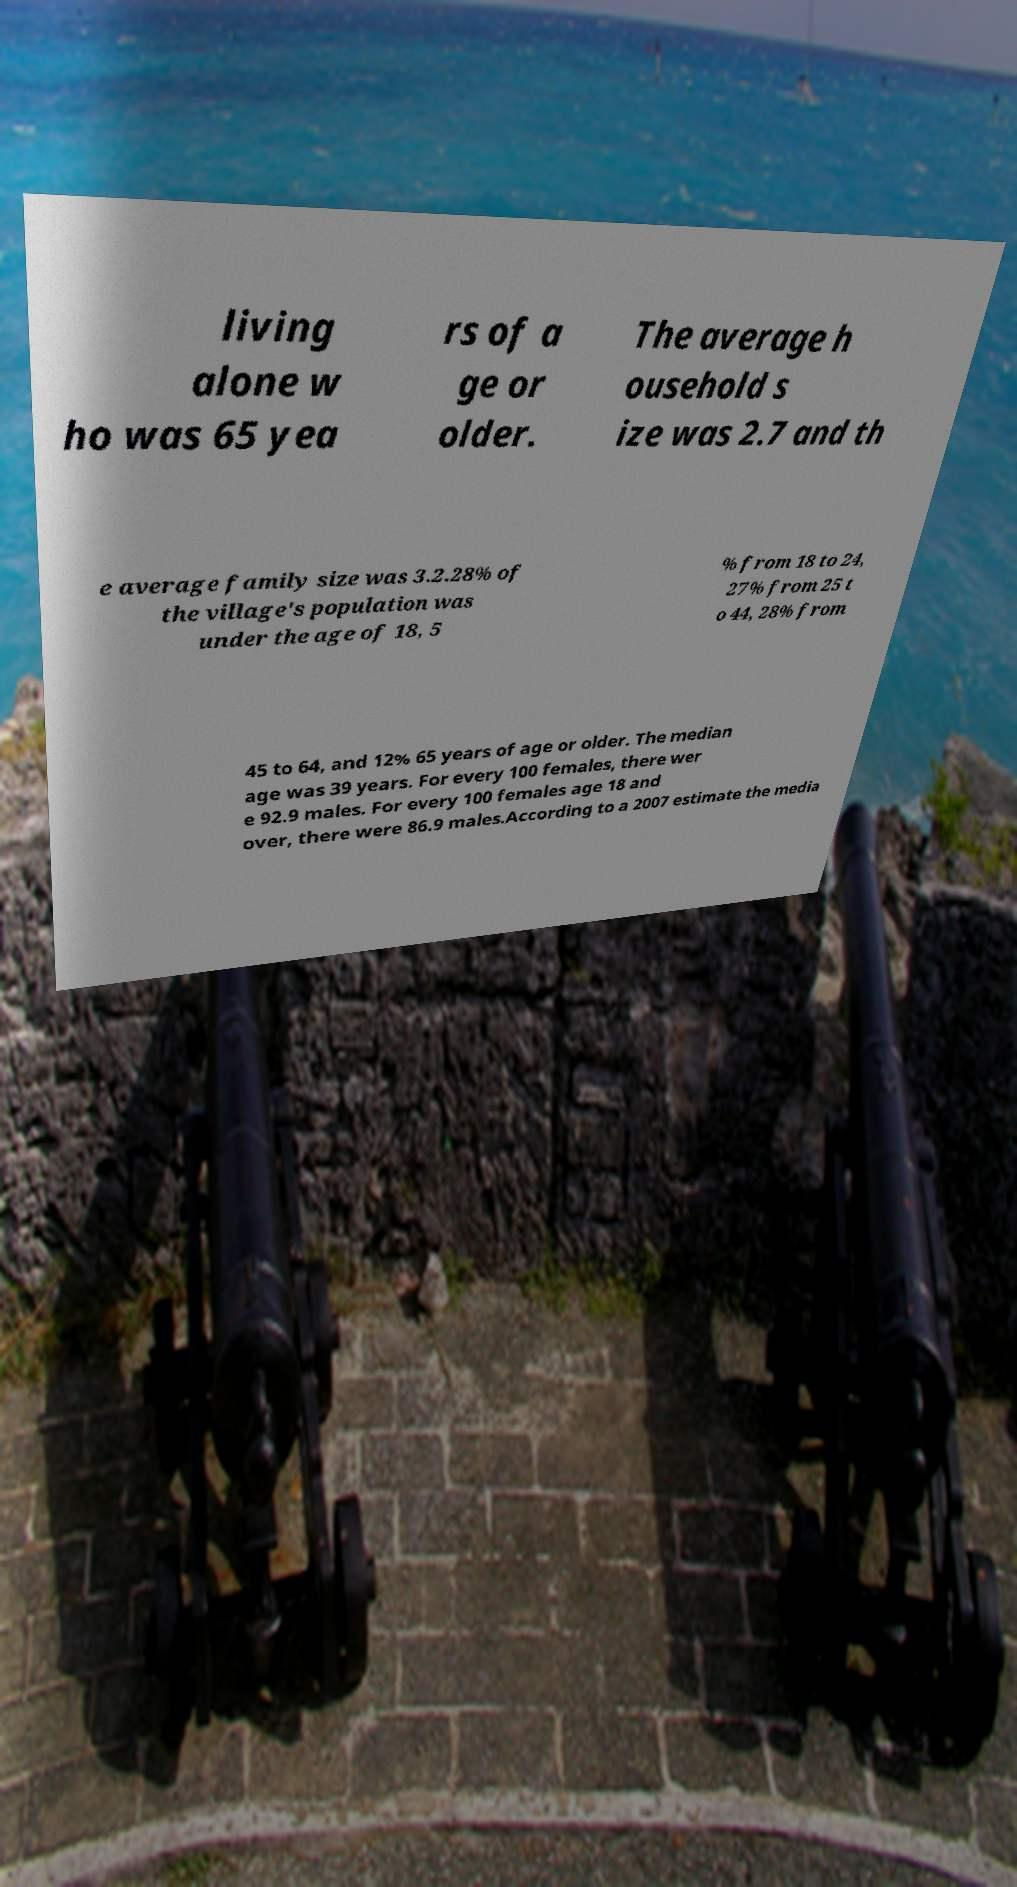Please identify and transcribe the text found in this image. living alone w ho was 65 yea rs of a ge or older. The average h ousehold s ize was 2.7 and th e average family size was 3.2.28% of the village's population was under the age of 18, 5 % from 18 to 24, 27% from 25 t o 44, 28% from 45 to 64, and 12% 65 years of age or older. The median age was 39 years. For every 100 females, there wer e 92.9 males. For every 100 females age 18 and over, there were 86.9 males.According to a 2007 estimate the media 